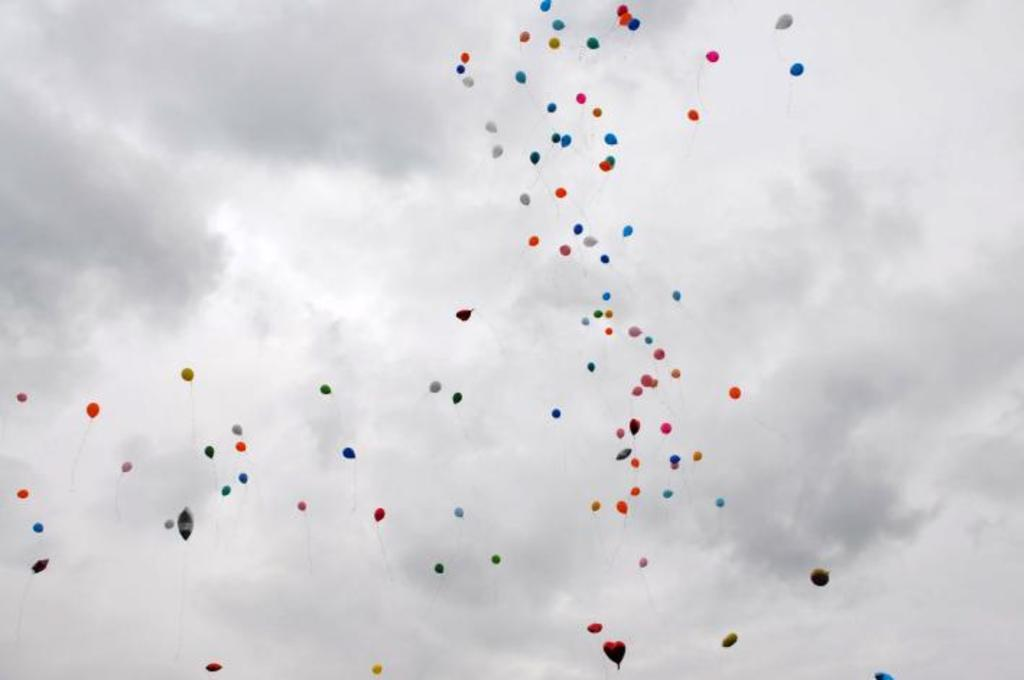What objects are present in the image? There are balloons in the image. Can you describe the colors of the balloons? The balloons are red, blue, pink, yellow, and white in color. What are the balloons doing in the image? The balloons are flying in the air. What can be seen in the background of the image? The sky is visible in the background of the image. What type of lumber is being sold in the shop in the image? There is no shop or lumber present in the image; it features balloons flying in the air. 